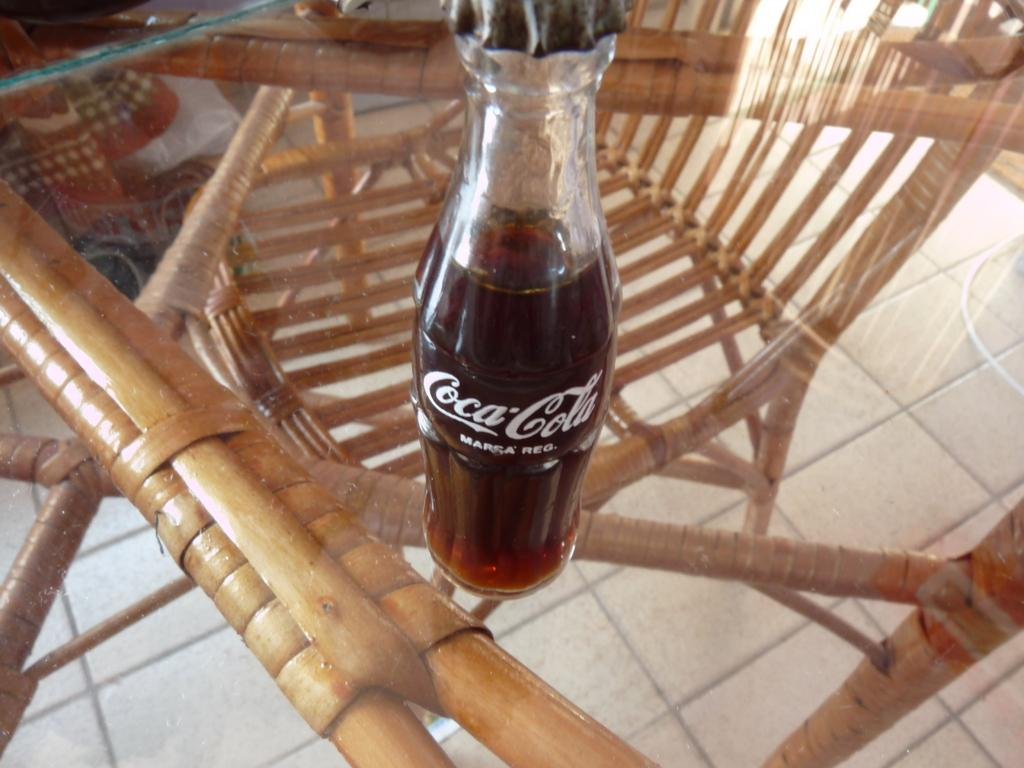What is the main object in the image? There is a coke bottle in the image. Where is the coke bottle located? The coke bottle is on a table. What type of meat is being served on the calendar in the image? There is no meat or calendar present in the image; it only features a coke bottle on a table. 